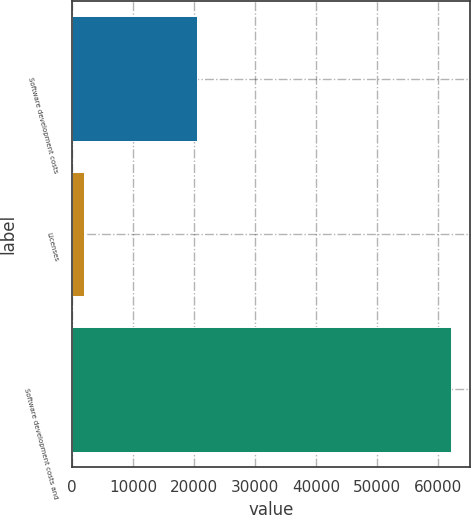<chart> <loc_0><loc_0><loc_500><loc_500><bar_chart><fcel>Software development costs<fcel>Licenses<fcel>Software development costs and<nl><fcel>20495<fcel>1988<fcel>61991<nl></chart> 